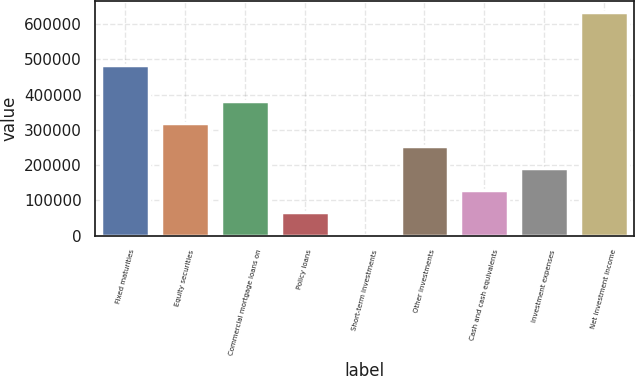Convert chart to OTSL. <chart><loc_0><loc_0><loc_500><loc_500><bar_chart><fcel>Fixed maturities<fcel>Equity securities<fcel>Commercial mortgage loans on<fcel>Policy loans<fcel>Short-term investments<fcel>Other investments<fcel>Cash and cash equivalents<fcel>Investment expenses<fcel>Net investment income<nl><fcel>484232<fcel>318954<fcel>382113<fcel>66317.1<fcel>3158<fcel>255794<fcel>129476<fcel>192635<fcel>634749<nl></chart> 